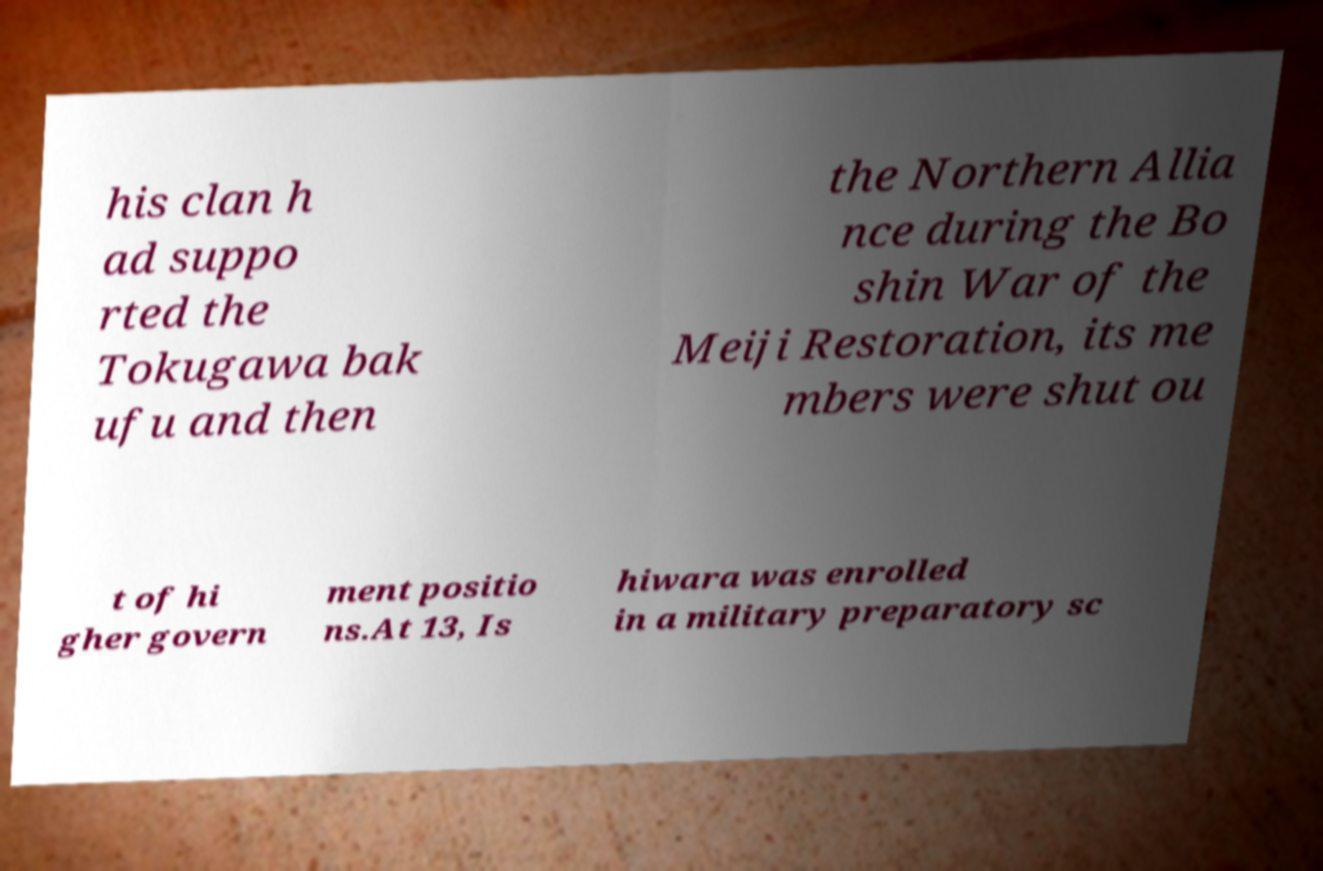Could you extract and type out the text from this image? his clan h ad suppo rted the Tokugawa bak ufu and then the Northern Allia nce during the Bo shin War of the Meiji Restoration, its me mbers were shut ou t of hi gher govern ment positio ns.At 13, Is hiwara was enrolled in a military preparatory sc 